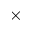<formula> <loc_0><loc_0><loc_500><loc_500>\times</formula> 